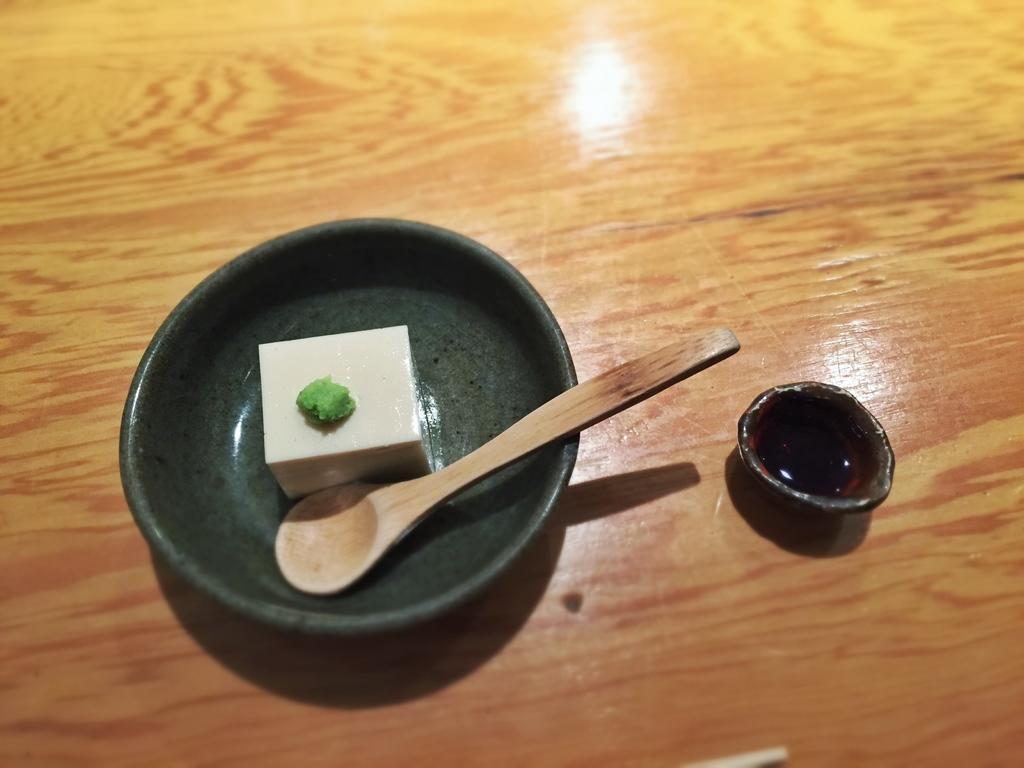Describe this image in one or two sentences. In this picture we can see bowl. In the bowl we can see food and spoon. This is cup. 